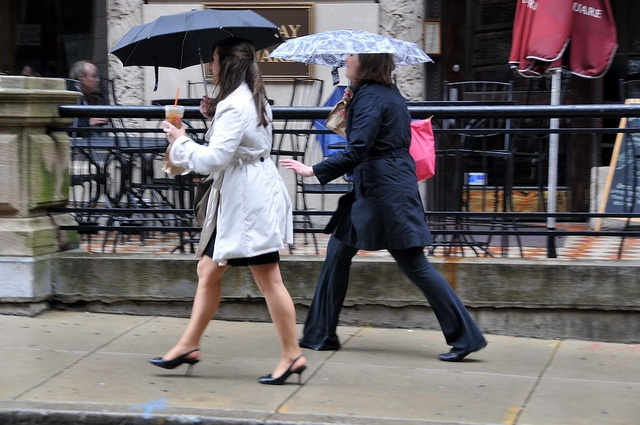Describe the objects in this image and their specific colors. I can see people in black, lavender, darkgray, and gray tones, people in black, navy, gray, and darkblue tones, chair in black, gray, and maroon tones, umbrella in black, maroon, and brown tones, and umbrella in black, darkgray, and gray tones in this image. 